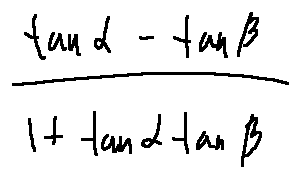Convert formula to latex. <formula><loc_0><loc_0><loc_500><loc_500>\frac { \tan \alpha - \tan \beta } { 1 + \tan \alpha \tan \beta }</formula> 